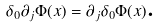Convert formula to latex. <formula><loc_0><loc_0><loc_500><loc_500>\delta _ { 0 } \partial _ { j } \Phi ( x ) = \partial _ { j } \delta _ { 0 } \Phi ( x ) \text {.}</formula> 